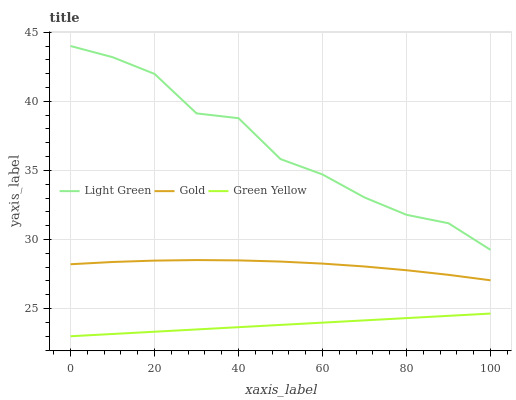Does Green Yellow have the minimum area under the curve?
Answer yes or no. Yes. Does Light Green have the maximum area under the curve?
Answer yes or no. Yes. Does Gold have the minimum area under the curve?
Answer yes or no. No. Does Gold have the maximum area under the curve?
Answer yes or no. No. Is Green Yellow the smoothest?
Answer yes or no. Yes. Is Light Green the roughest?
Answer yes or no. Yes. Is Gold the smoothest?
Answer yes or no. No. Is Gold the roughest?
Answer yes or no. No. Does Gold have the lowest value?
Answer yes or no. No. Does Light Green have the highest value?
Answer yes or no. Yes. Does Gold have the highest value?
Answer yes or no. No. Is Gold less than Light Green?
Answer yes or no. Yes. Is Light Green greater than Green Yellow?
Answer yes or no. Yes. Does Gold intersect Light Green?
Answer yes or no. No. 